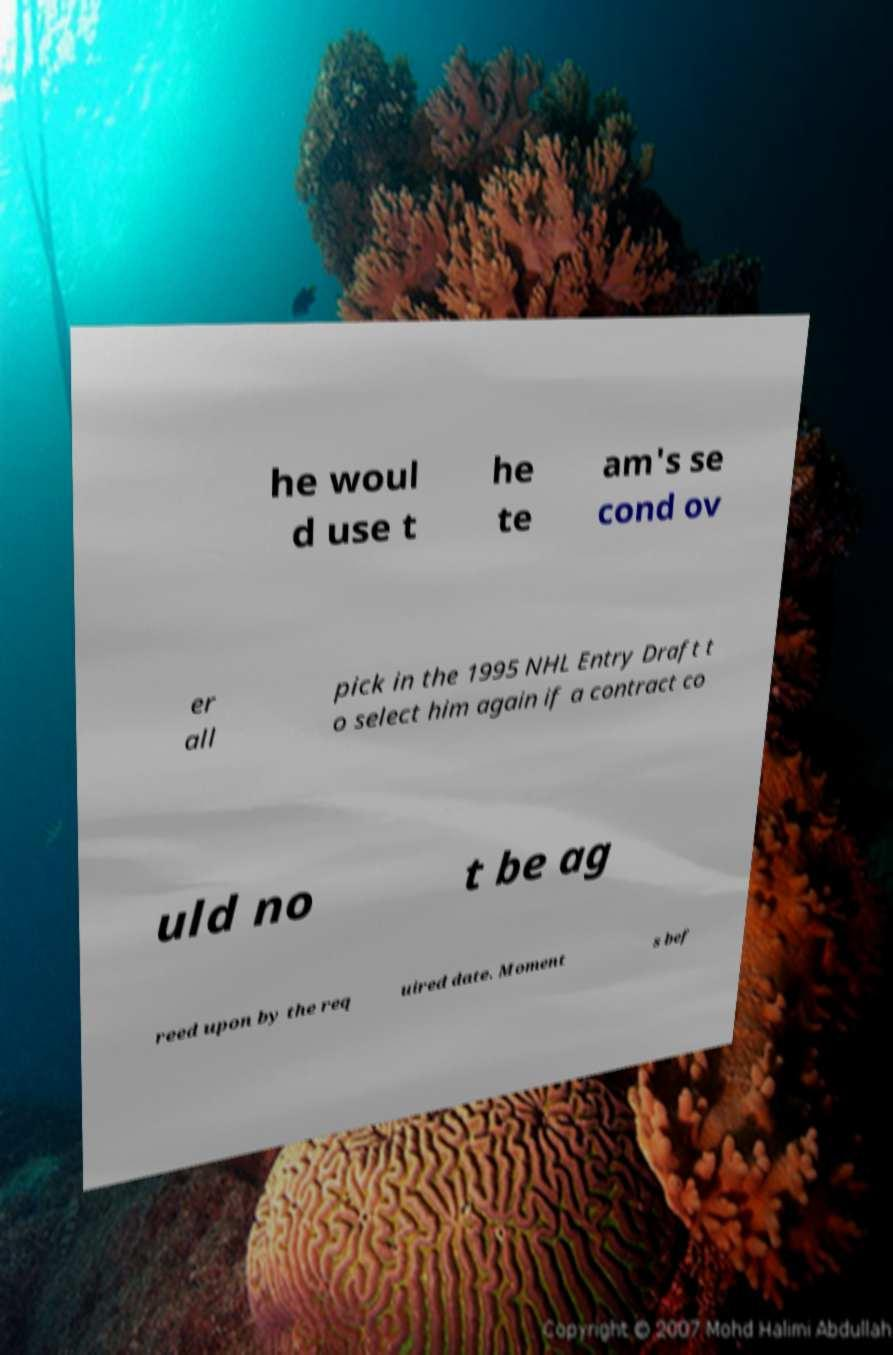I need the written content from this picture converted into text. Can you do that? he woul d use t he te am's se cond ov er all pick in the 1995 NHL Entry Draft t o select him again if a contract co uld no t be ag reed upon by the req uired date. Moment s bef 